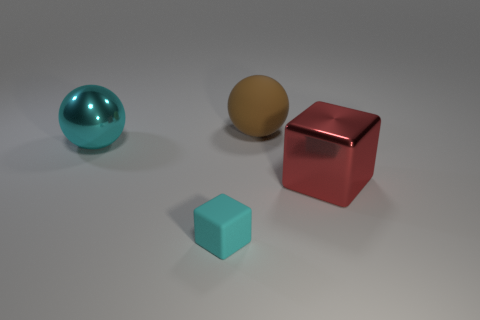How many objects are in front of the big brown rubber sphere and behind the cyan rubber block?
Provide a short and direct response. 2. Is there another big brown object made of the same material as the big brown thing?
Your answer should be very brief. No. What is the size of the metal ball that is the same color as the matte cube?
Keep it short and to the point. Large. How many blocks are large red things or tiny cyan objects?
Your answer should be very brief. 2. What size is the brown rubber sphere?
Give a very brief answer. Large. There is a large cyan thing; how many large brown rubber spheres are in front of it?
Provide a succinct answer. 0. What is the size of the cyan rubber thing in front of the ball in front of the large brown ball?
Your answer should be compact. Small. Do the cyan thing that is left of the tiny rubber cube and the matte thing that is right of the cyan cube have the same shape?
Your answer should be very brief. Yes. There is a matte thing that is behind the metal object that is to the left of the red metal cube; what shape is it?
Keep it short and to the point. Sphere. There is a thing that is to the left of the large block and in front of the large cyan object; what size is it?
Give a very brief answer. Small. 